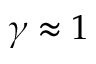Convert formula to latex. <formula><loc_0><loc_0><loc_500><loc_500>\gamma \approx 1</formula> 